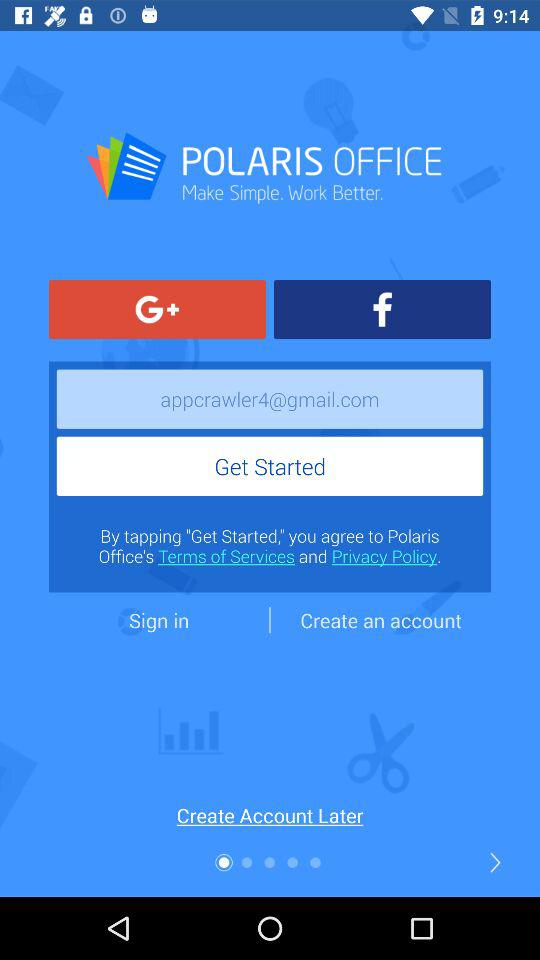What is the application name? The application name is "POLARIS OFFICE". 